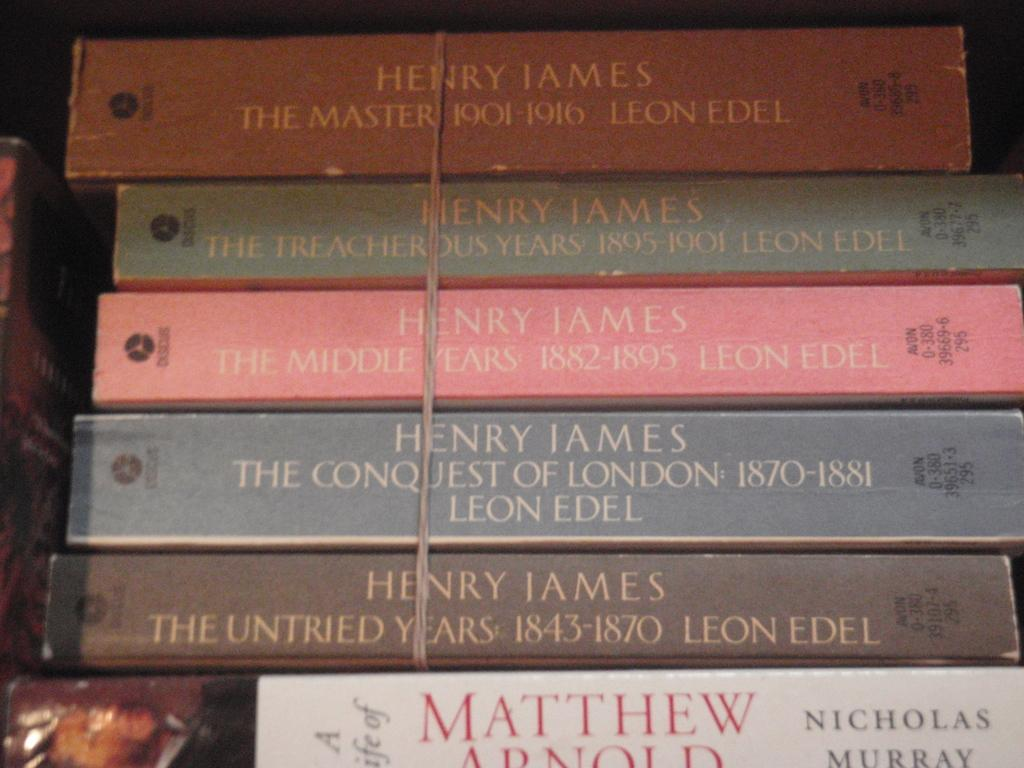<image>
Write a terse but informative summary of the picture. Four books by Henry James are tied with a string and sit on top of a book by Nicholas Murray. 